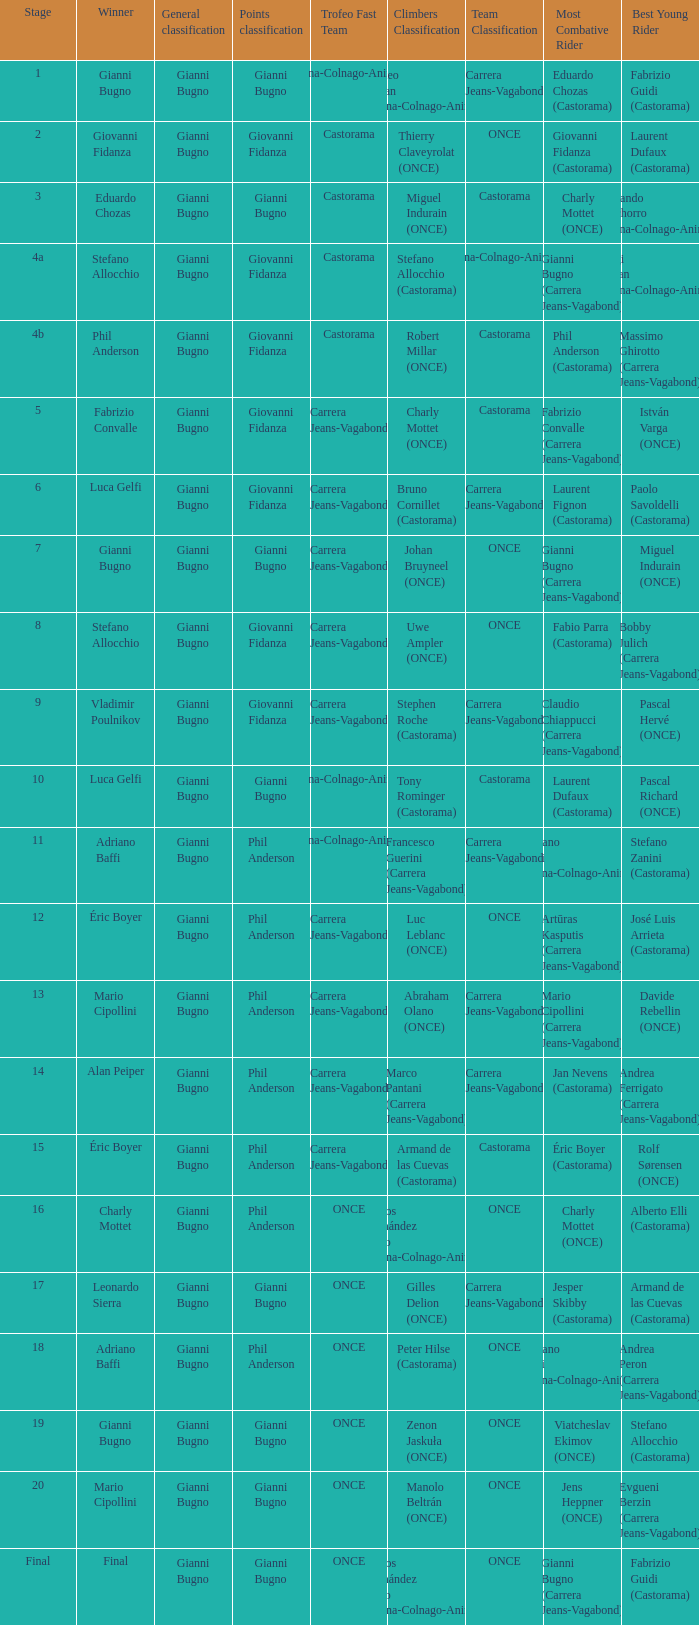Help me parse the entirety of this table. {'header': ['Stage', 'Winner', 'General classification', 'Points classification', 'Trofeo Fast Team', 'Climbers Classification', 'Team Classification', 'Most Combative Rider', 'Best Young Rider '], 'rows': [['1', 'Gianni Bugno', 'Gianni Bugno', 'Gianni Bugno', 'Diana-Colnago-Animex', 'Matteo Furlan (Diana-Colnago-Animex)', 'Carrera Jeans-Vagabond', 'Eduardo Chozas (Castorama)', 'Fabrizio Guidi (Castorama)'], ['2', 'Giovanni Fidanza', 'Gianni Bugno', 'Giovanni Fidanza', 'Castorama', 'Thierry Claveyrolat (ONCE)', 'ONCE', 'Giovanni Fidanza (Castorama)', 'Laurent Dufaux (Castorama)'], ['3', 'Eduardo Chozas', 'Gianni Bugno', 'Gianni Bugno', 'Castorama', 'Miguel Indurain (ONCE)', 'Castorama', 'Charly Mottet (ONCE)', 'Fernando Chichorro (Diana-Colnago-Animex)'], ['4a', 'Stefano Allocchio', 'Gianni Bugno', 'Giovanni Fidanza', 'Castorama', 'Stefano Allocchio (Castorama)', 'Diana-Colnago-Animex', 'Gianni Bugno (Carrera Jeans-Vagabond)', 'Luigi Furlan (Diana-Colnago-Animex)'], ['4b', 'Phil Anderson', 'Gianni Bugno', 'Giovanni Fidanza', 'Castorama', 'Robert Millar (ONCE)', 'Castorama', 'Phil Anderson (Castorama)', 'Massimo Ghirotto (Carrera Jeans-Vagabond)'], ['5', 'Fabrizio Convalle', 'Gianni Bugno', 'Giovanni Fidanza', 'Carrera Jeans-Vagabond', 'Charly Mottet (ONCE)', 'Castorama', 'Fabrizio Convalle (Carrera Jeans-Vagabond)', 'István Varga (ONCE)'], ['6', 'Luca Gelfi', 'Gianni Bugno', 'Giovanni Fidanza', 'Carrera Jeans-Vagabond', 'Bruno Cornillet (Castorama)', 'Carrera Jeans-Vagabond', 'Laurent Fignon (Castorama)', 'Paolo Savoldelli (Castorama)'], ['7', 'Gianni Bugno', 'Gianni Bugno', 'Gianni Bugno', 'Carrera Jeans-Vagabond', 'Johan Bruyneel (ONCE)', 'ONCE', 'Gianni Bugno (Carrera Jeans-Vagabond)', 'Miguel Indurain (ONCE)'], ['8', 'Stefano Allocchio', 'Gianni Bugno', 'Giovanni Fidanza', 'Carrera Jeans-Vagabond', 'Uwe Ampler (ONCE)', 'ONCE', 'Fabio Parra (Castorama)', 'Bobby Julich (Carrera Jeans-Vagabond)'], ['9', 'Vladimir Poulnikov', 'Gianni Bugno', 'Giovanni Fidanza', 'Carrera Jeans-Vagabond', 'Stephen Roche (Castorama)', 'Carrera Jeans-Vagabond', 'Claudio Chiappucci (Carrera Jeans-Vagabond)', 'Pascal Hervé (ONCE)'], ['10', 'Luca Gelfi', 'Gianni Bugno', 'Gianni Bugno', 'Diana-Colnago-Animex', 'Tony Rominger (Castorama)', 'Castorama', 'Laurent Dufaux (Castorama)', 'Pascal Richard (ONCE)'], ['11', 'Adriano Baffi', 'Gianni Bugno', 'Phil Anderson', 'Diana-Colnago-Animex', 'Francesco Guerini (Carrera Jeans-Vagabond)', 'Carrera Jeans-Vagabond', 'Adriano Baffi (Diana-Colnago-Animex)', 'Stefano Zanini (Castorama)'], ['12', 'Éric Boyer', 'Gianni Bugno', 'Phil Anderson', 'Carrera Jeans-Vagabond', 'Luc Leblanc (ONCE)', 'ONCE', 'Artūras Kasputis (Carrera Jeans-Vagabond)', 'José Luis Arrieta (Castorama)'], ['13', 'Mario Cipollini', 'Gianni Bugno', 'Phil Anderson', 'Carrera Jeans-Vagabond', 'Abraham Olano (ONCE)', 'Carrera Jeans-Vagabond', 'Mario Cipollini (Carrera Jeans-Vagabond)', 'Davide Rebellin (ONCE)'], ['14', 'Alan Peiper', 'Gianni Bugno', 'Phil Anderson', 'Carrera Jeans-Vagabond', 'Marco Pantani (Carrera Jeans-Vagabond)', 'Carrera Jeans-Vagabond', 'Jan Nevens (Castorama)', 'Andrea Ferrigato (Carrera Jeans-Vagabond)'], ['15', 'Éric Boyer', 'Gianni Bugno', 'Phil Anderson', 'Carrera Jeans-Vagabond', 'Armand de las Cuevas (Castorama)', 'Castorama', 'Éric Boyer (Castorama)', 'Rolf Sørensen (ONCE)'], ['16', 'Charly Mottet', 'Gianni Bugno', 'Phil Anderson', 'ONCE', 'Carlos Hernández Bailo (Diana-Colnago-Animex)', 'ONCE', 'Charly Mottet (ONCE)', 'Alberto Elli (Castorama)'], ['17', 'Leonardo Sierra', 'Gianni Bugno', 'Gianni Bugno', 'ONCE', 'Gilles Delion (ONCE)', 'Carrera Jeans-Vagabond', 'Jesper Skibby (Castorama)', 'Armand de las Cuevas (Castorama)'], ['18', 'Adriano Baffi', 'Gianni Bugno', 'Phil Anderson', 'ONCE', 'Peter Hilse (Castorama)', 'ONCE', 'Adriano Baffi (Diana-Colnago-Animex)', 'Andrea Peron (Carrera Jeans-Vagabond)'], ['19', 'Gianni Bugno', 'Gianni Bugno', 'Gianni Bugno', 'ONCE', 'Zenon Jaskuła (ONCE)', 'ONCE', 'Viatcheslav Ekimov (ONCE)', 'Stefano Allocchio (Castorama)'], ['20', 'Mario Cipollini', 'Gianni Bugno', 'Gianni Bugno', 'ONCE', 'Manolo Beltrán (ONCE)', 'ONCE', 'Jens Heppner (ONCE)', 'Evgueni Berzin (Carrera Jeans-Vagabond)'], ['Final', 'Final', 'Gianni Bugno', 'Gianni Bugno', 'ONCE', 'Carlos Hernández Bailo (Diana-Colnago-Animex)', 'ONCE', 'Gianni Bugno (Carrera Jeans-Vagabond)', 'Fabrizio Guidi (Castorama)']]} Who is the points classification in stage 1? Gianni Bugno. 